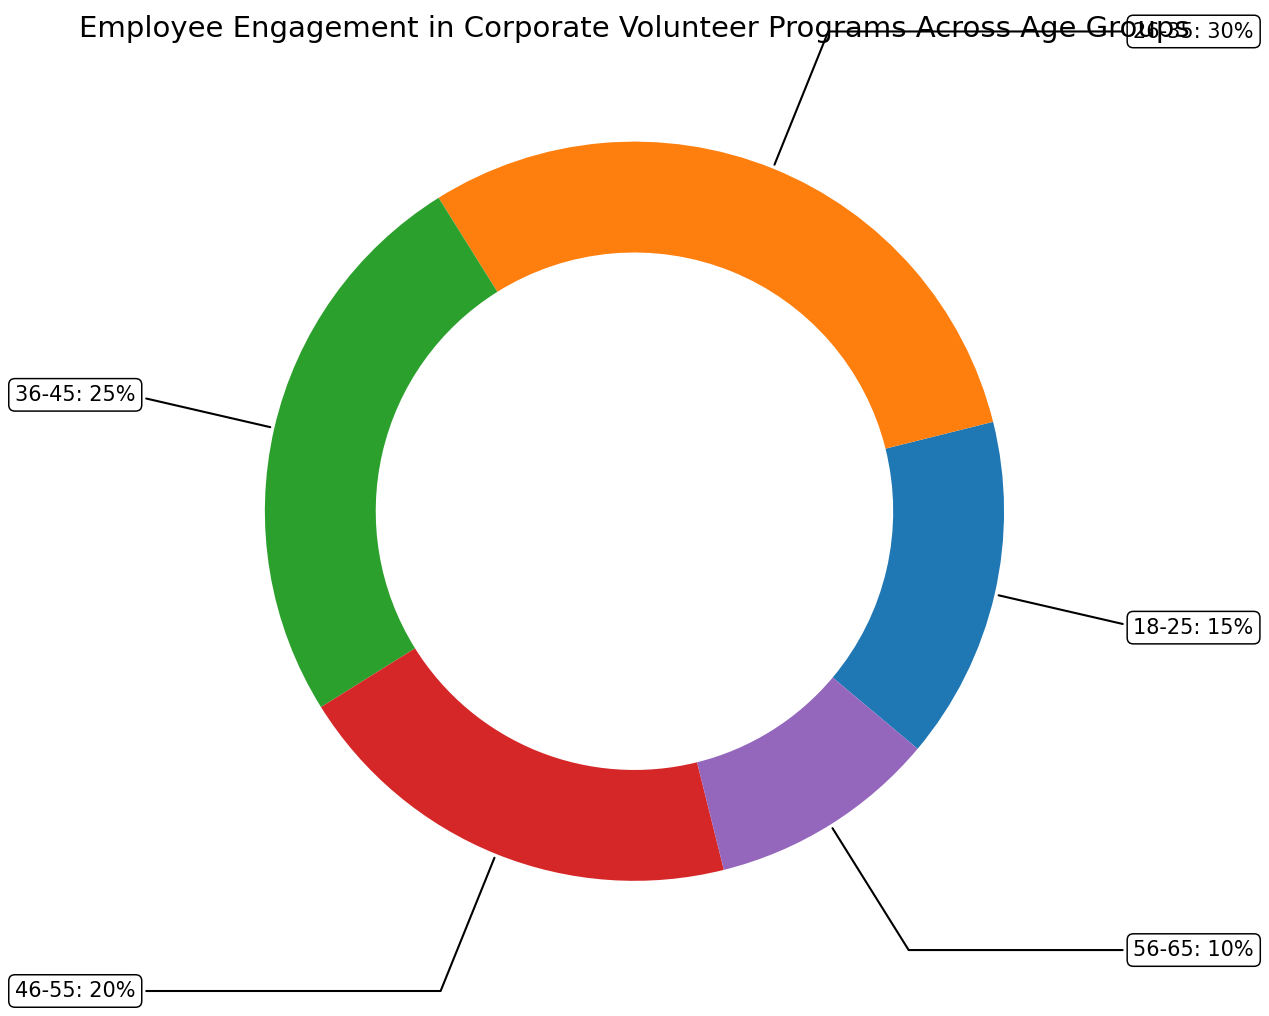What age group has the highest participation percentage in corporate volunteer programs? Look at the rings and find the largest segment. The 26-35 age group has a participation percentage of 30%, which is the highest.
Answer: 26-35 Which age group has the lowest participation percentage in corporate volunteer programs? Look at the rings and find the smallest segment. The 56-65 age group has the lowest participation percentage, which is 10%.
Answer: 56-65 What is the total participation percentage of employees aged 36-45 and 46-55 combined? Sum the percentages for the age groups 36-45 and 46-55: 25% + 20% = 45%.
Answer: 45% By how much does the participation percentage of employees aged 26-35 exceed that of employees aged 18-25? Subtract the participation percentage of the 18-25 age group from that of the 26-35 age group: 30% - 15% = 15%.
Answer: 15% What is the difference in participation percentage between the age group 46-55 and the age group 56-65? Subtract the participation percentage of the 56-65 age group from that of the 46-55 age group: 20% - 10% = 10%.
Answer: 10% What is the average participation percentage of all age groups? Sum all participation percentages and divide by the number of age groups: (15 + 30 + 25 + 20 + 10) / 5 = 20%.
Answer: 20% Rank the age groups from highest to lowest participation percentage. List the age groups by their participation percentages: 26-35 (30%), 36-45 (25%), 46-55 (20%), 18-25 (15%), 56-65 (10%).
Answer: 26-35, 36-45, 46-55, 18-25, 56-65 Which two consecutive age groups have the smallest difference in their participation percentages? Consider the differences between consecutive age groups: (26-35) and (36-45) = 5%, (36-45) and (46-55) = 5%, (46-55) and (56-65) = 10%, (18-25) and (26-35) = 15%. The smallest difference is 5%.
Answer: 26-35 and 36-45; 36-45 and 46-55 